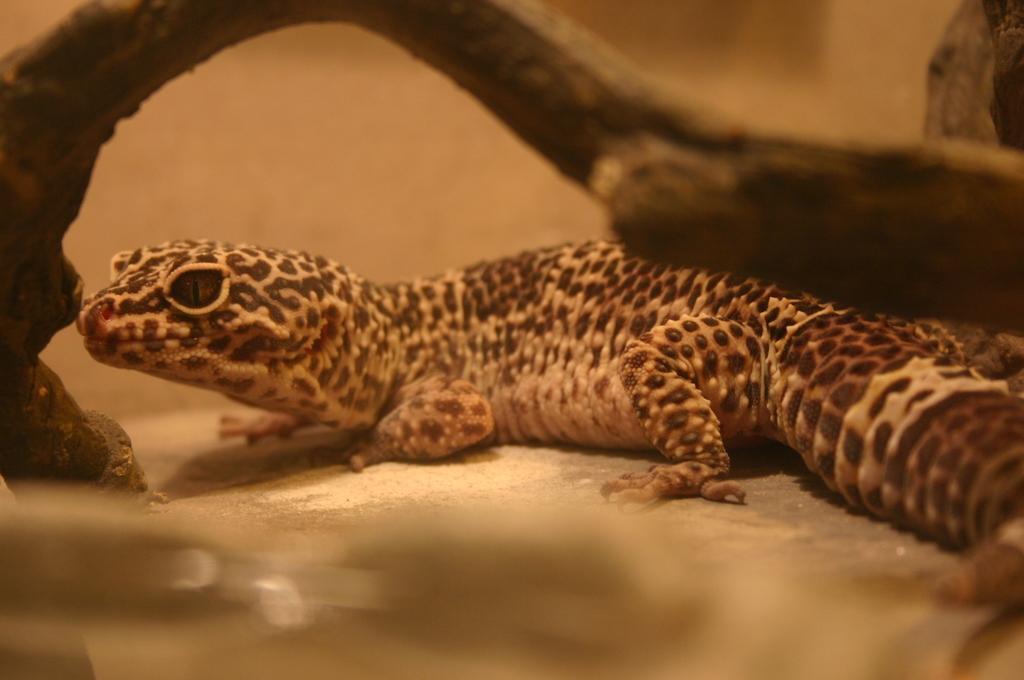Please provide a concise description of this image. This is a reptile from the lizard family, which is named as western whiptail. This looks like a wooden branch. 